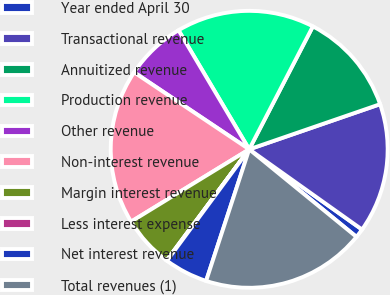Convert chart to OTSL. <chart><loc_0><loc_0><loc_500><loc_500><pie_chart><fcel>Year ended April 30<fcel>Transactional revenue<fcel>Annuitized revenue<fcel>Production revenue<fcel>Other revenue<fcel>Non-interest revenue<fcel>Margin interest revenue<fcel>Less interest expense<fcel>Net interest revenue<fcel>Total revenues (1)<nl><fcel>1.06%<fcel>15.12%<fcel>12.11%<fcel>16.13%<fcel>7.09%<fcel>18.13%<fcel>6.08%<fcel>0.06%<fcel>5.08%<fcel>19.14%<nl></chart> 